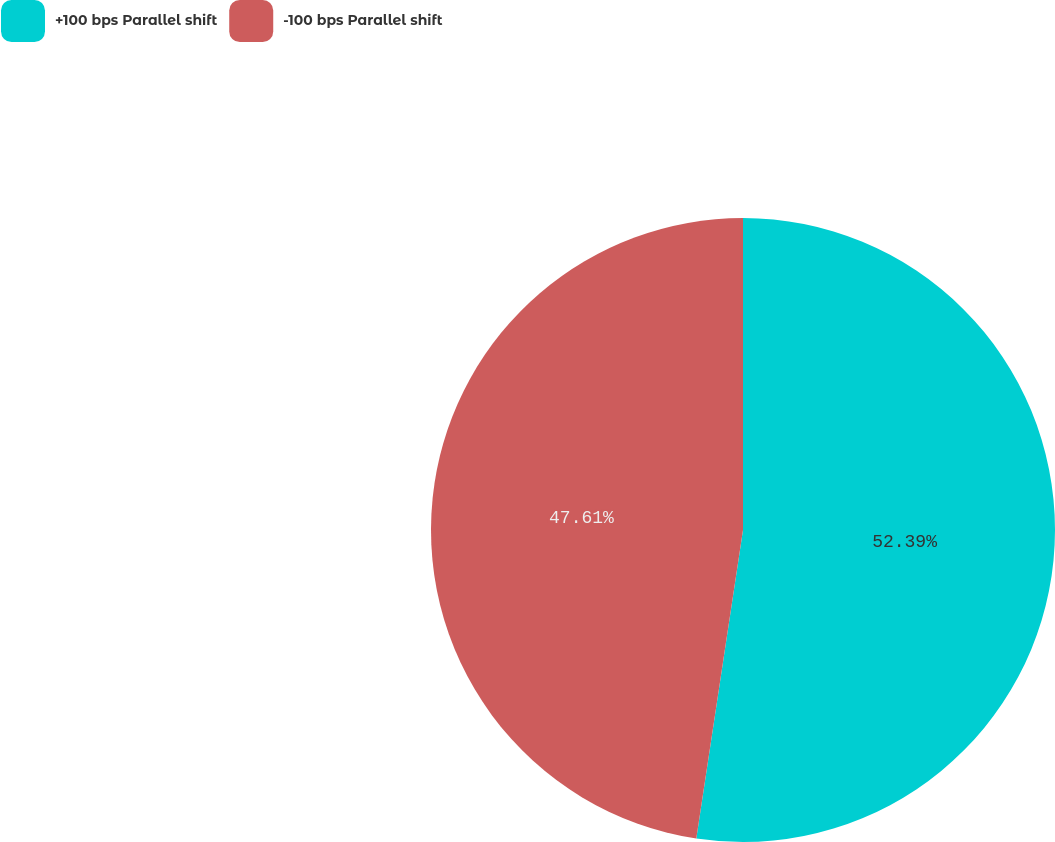Convert chart. <chart><loc_0><loc_0><loc_500><loc_500><pie_chart><fcel>+100 bps Parallel shift<fcel>-100 bps Parallel shift<nl><fcel>52.39%<fcel>47.61%<nl></chart> 